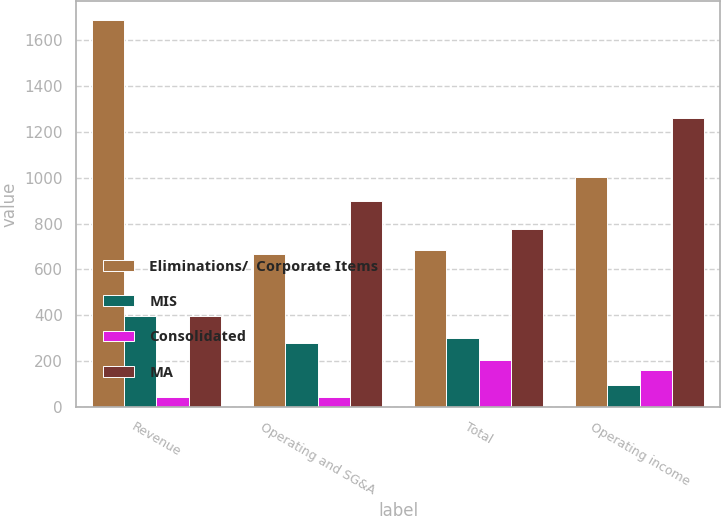<chart> <loc_0><loc_0><loc_500><loc_500><stacked_bar_chart><ecel><fcel>Revenue<fcel>Operating and SG&A<fcel>Total<fcel>Operating income<nl><fcel>Eliminations/  Corporate Items<fcel>1685.6<fcel>666.1<fcel>683.4<fcel>1002.2<nl><fcel>MIS<fcel>397.3<fcel>278.4<fcel>300.6<fcel>96.7<nl><fcel>Consolidated<fcel>45.8<fcel>45.8<fcel>206.4<fcel>160.6<nl><fcel>MA<fcel>397.3<fcel>898.7<fcel>777.6<fcel>1259.5<nl></chart> 